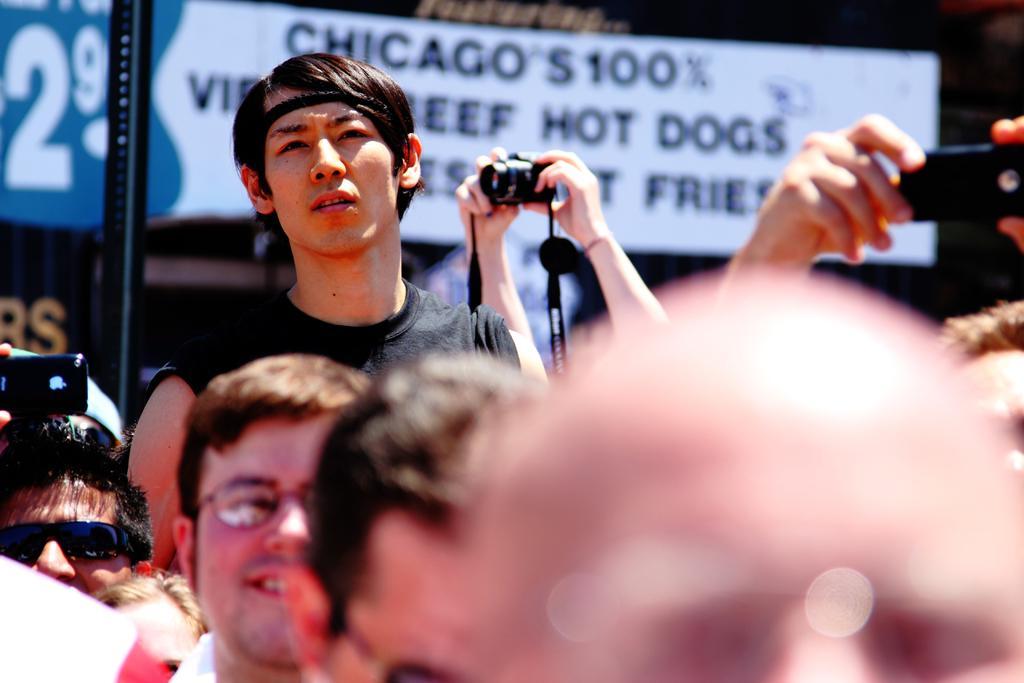How would you summarize this image in a sentence or two? In this Image I see number of people, in which few of them are holding the camera and the phones. 